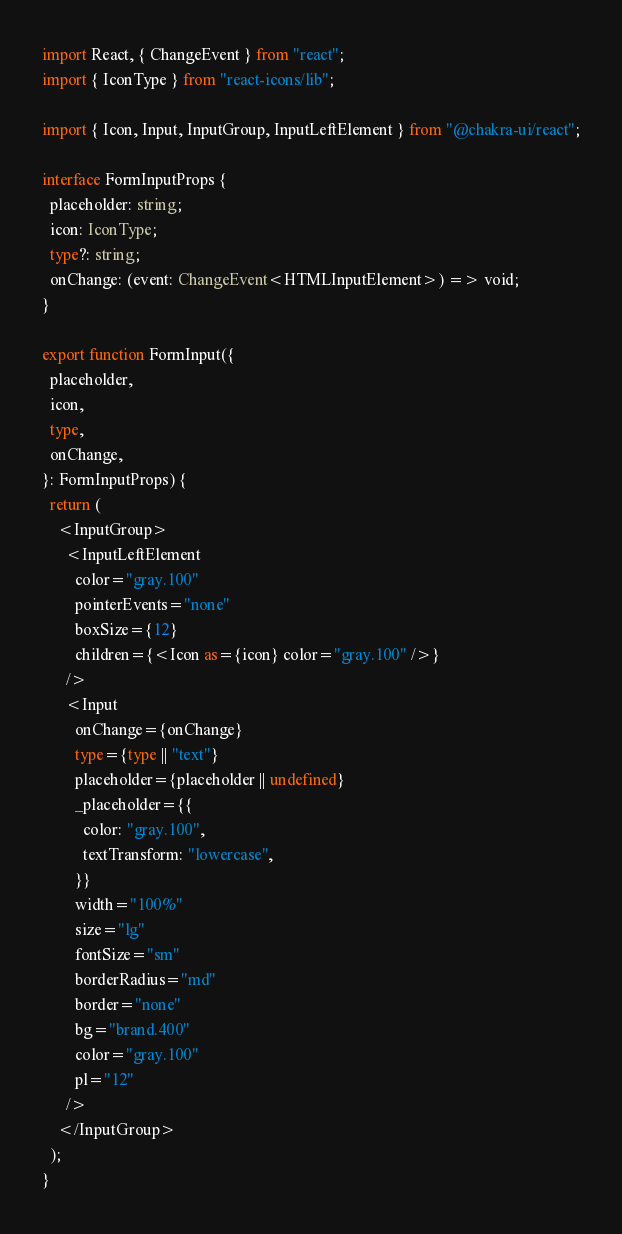Convert code to text. <code><loc_0><loc_0><loc_500><loc_500><_TypeScript_>import React, { ChangeEvent } from "react";
import { IconType } from "react-icons/lib";

import { Icon, Input, InputGroup, InputLeftElement } from "@chakra-ui/react";

interface FormInputProps {
  placeholder: string;
  icon: IconType;
  type?: string;
  onChange: (event: ChangeEvent<HTMLInputElement>) => void;
}

export function FormInput({
  placeholder,
  icon,
  type,
  onChange,
}: FormInputProps) {
  return (
    <InputGroup>
      <InputLeftElement
        color="gray.100"
        pointerEvents="none"
        boxSize={12}
        children={<Icon as={icon} color="gray.100" />}
      />
      <Input
        onChange={onChange}
        type={type || "text"}
        placeholder={placeholder || undefined}
        _placeholder={{
          color: "gray.100",
          textTransform: "lowercase",
        }}
        width="100%"
        size="lg"
        fontSize="sm"
        borderRadius="md"
        border="none"
        bg="brand.400"
        color="gray.100"
        pl="12"
      />
    </InputGroup>
  );
}
</code> 